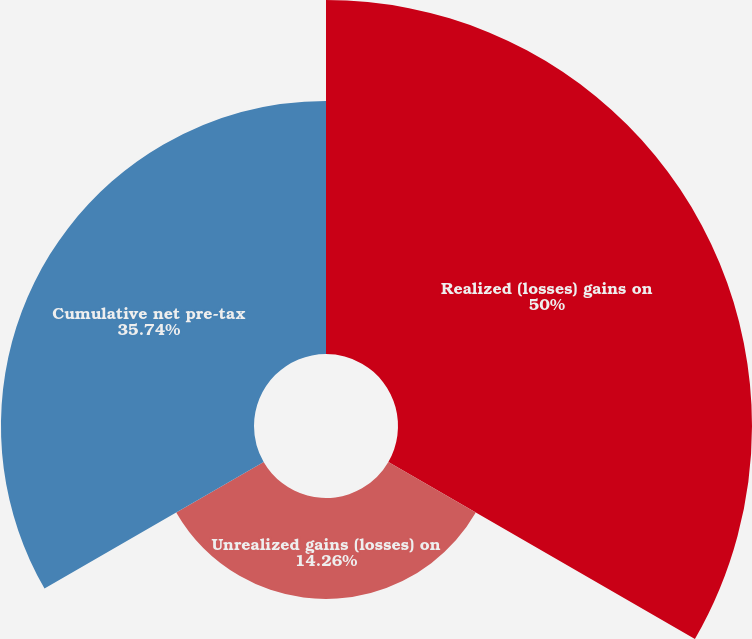Convert chart to OTSL. <chart><loc_0><loc_0><loc_500><loc_500><pie_chart><fcel>Realized (losses) gains on<fcel>Unrealized gains (losses) on<fcel>Cumulative net pre-tax<nl><fcel>50.0%<fcel>14.26%<fcel>35.74%<nl></chart> 